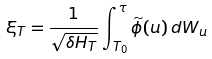Convert formula to latex. <formula><loc_0><loc_0><loc_500><loc_500>\xi _ { T } = \frac { 1 } { \sqrt { \delta H _ { T } } } \int ^ { \tau } _ { T _ { 0 } } \widetilde { \phi } ( u ) \, d W _ { u }</formula> 